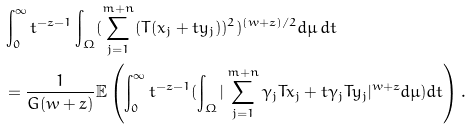Convert formula to latex. <formula><loc_0><loc_0><loc_500><loc_500>& \int _ { 0 } ^ { \infty } t ^ { - z - 1 } \int _ { \Omega } ( \sum _ { j = 1 } ^ { m + n } ( T ( x _ { j } + t y _ { j } ) ) ^ { 2 } ) ^ { ( w + z ) / 2 } d \mu \, d t \\ & = \frac { 1 } { G ( w + z ) } \mathbb { E } \left ( \int _ { 0 } ^ { \infty } t ^ { - z - 1 } ( \int _ { \Omega } | \sum _ { j = 1 } ^ { m + n } \gamma _ { j } T x _ { j } + t \gamma _ { j } T y _ { j } | ^ { w + z } d \mu ) d t \right ) .</formula> 